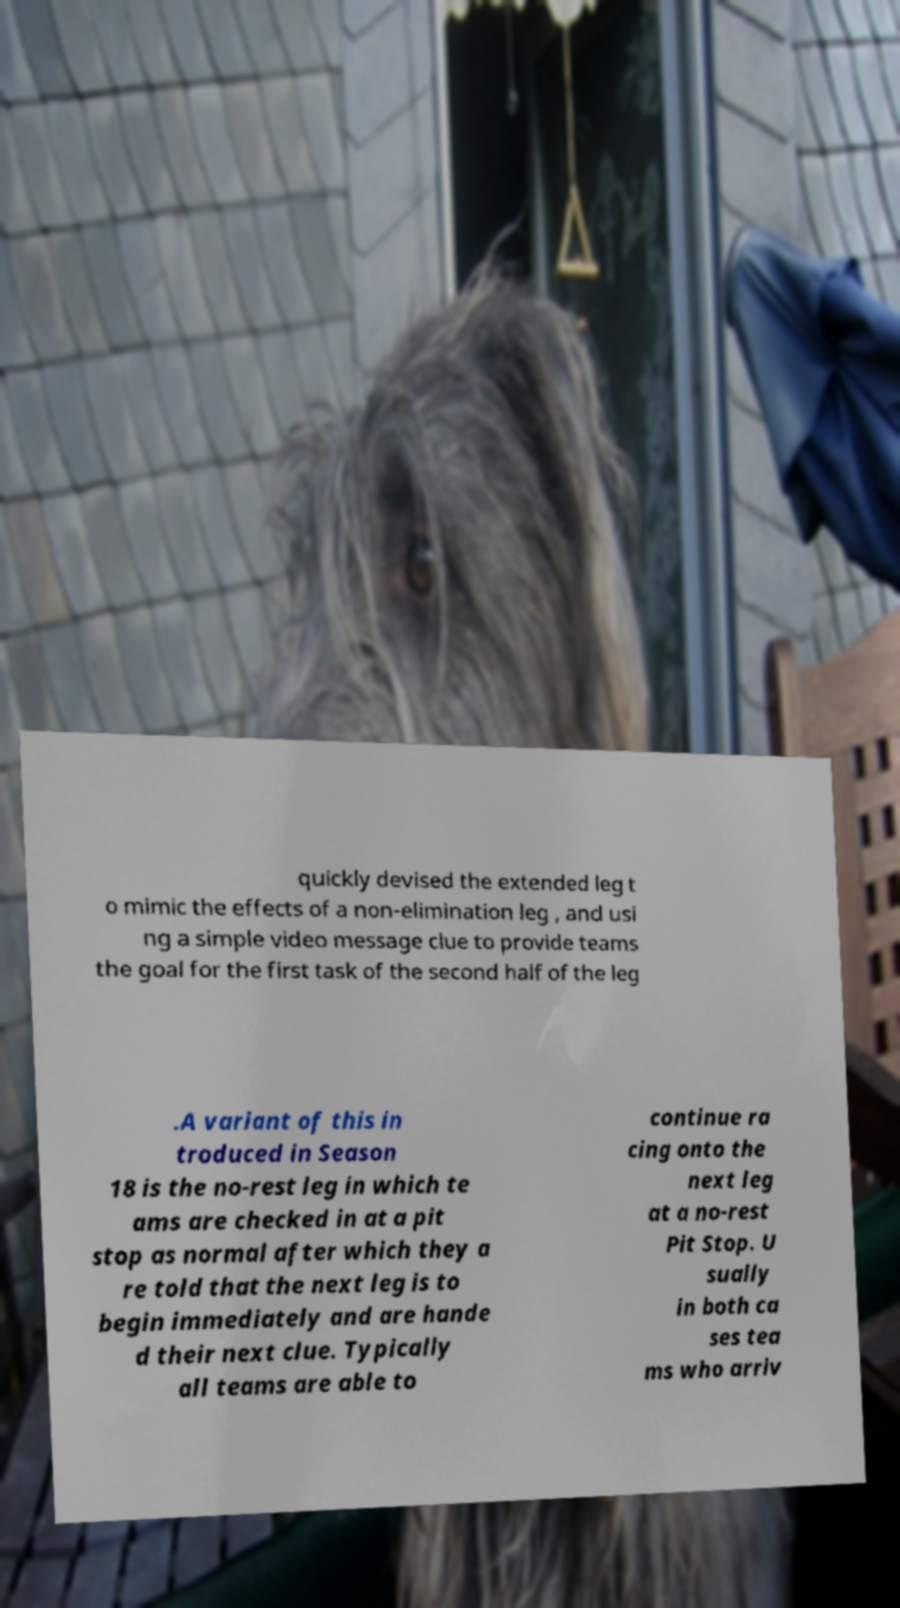Can you accurately transcribe the text from the provided image for me? quickly devised the extended leg t o mimic the effects of a non-elimination leg , and usi ng a simple video message clue to provide teams the goal for the first task of the second half of the leg .A variant of this in troduced in Season 18 is the no-rest leg in which te ams are checked in at a pit stop as normal after which they a re told that the next leg is to begin immediately and are hande d their next clue. Typically all teams are able to continue ra cing onto the next leg at a no-rest Pit Stop. U sually in both ca ses tea ms who arriv 